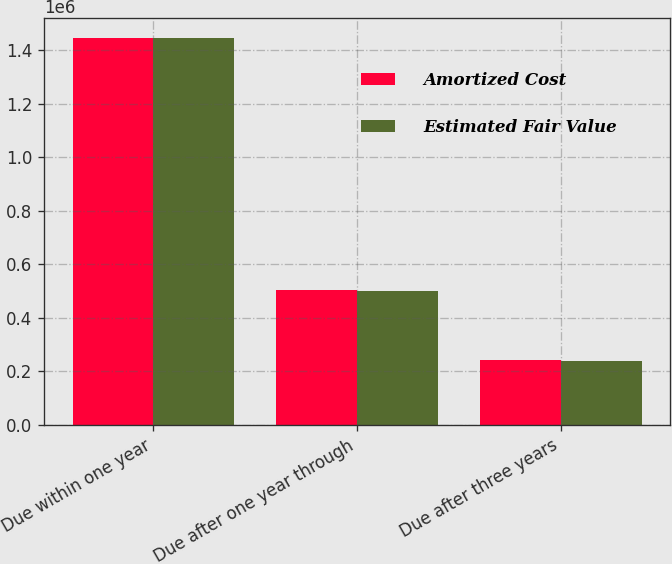Convert chart. <chart><loc_0><loc_0><loc_500><loc_500><stacked_bar_chart><ecel><fcel>Due within one year<fcel>Due after one year through<fcel>Due after three years<nl><fcel>Amortized Cost<fcel>1.44654e+06<fcel>502082<fcel>242037<nl><fcel>Estimated Fair Value<fcel>1.44613e+06<fcel>499592<fcel>238845<nl></chart> 